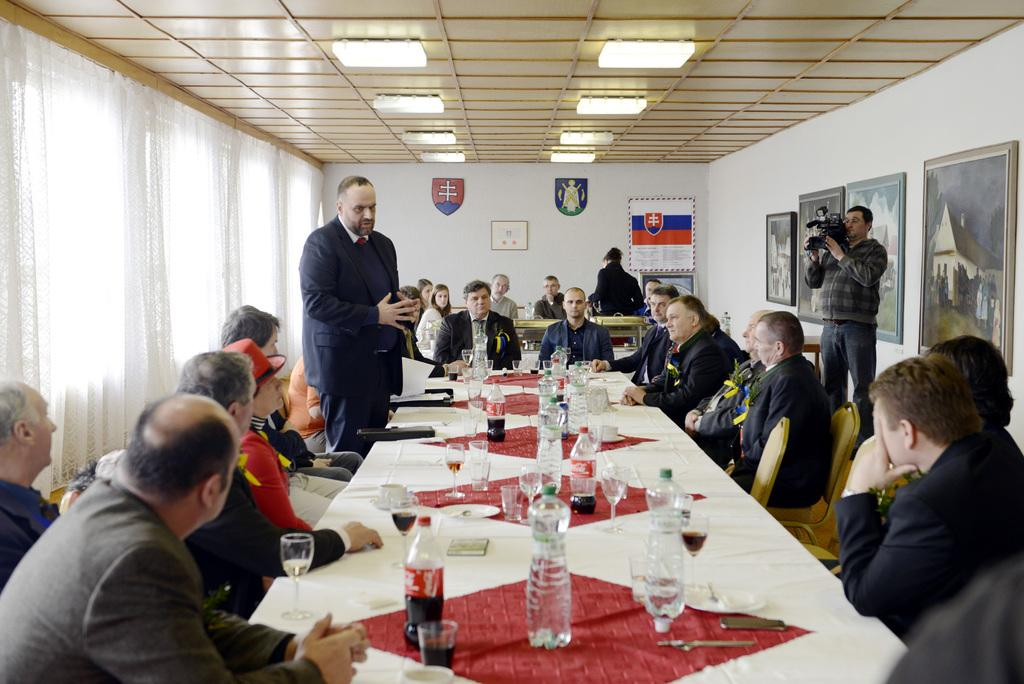What is the main activity of the people in the image? The main activity of the people in the image is a meeting, as they are seated and engaged in conversation. Can you describe the actions of the two men standing in the image? One man is standing and taking a video, while the other man is standing and speaking with others. What can be inferred about the purpose of the meeting from the presence of the man taking a video? The man taking a video might be capturing important information or moments from the meeting for future reference or sharing. How many boys are present in the image? There is no mention of boys in the image, as the facts provided only refer to a group of people and two men standing. 